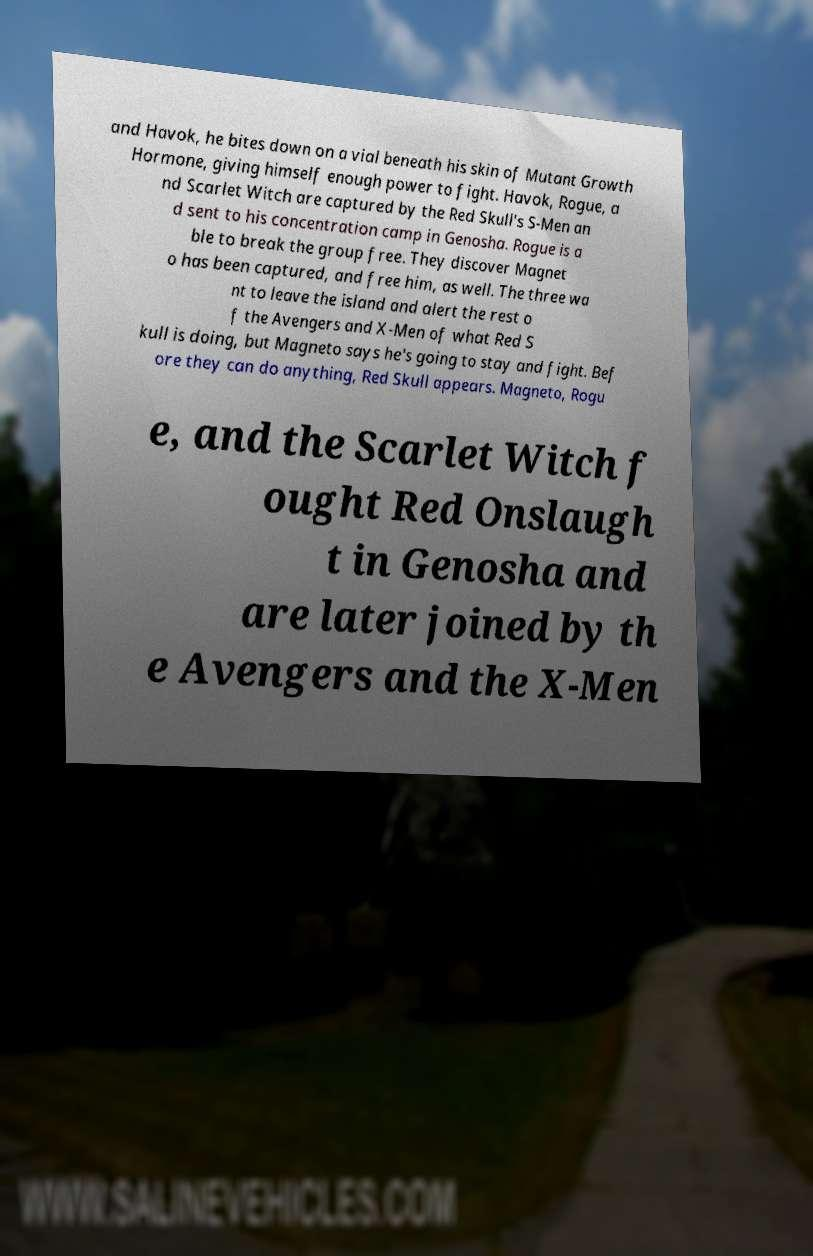For documentation purposes, I need the text within this image transcribed. Could you provide that? and Havok, he bites down on a vial beneath his skin of Mutant Growth Hormone, giving himself enough power to fight. Havok, Rogue, a nd Scarlet Witch are captured by the Red Skull's S-Men an d sent to his concentration camp in Genosha. Rogue is a ble to break the group free. They discover Magnet o has been captured, and free him, as well. The three wa nt to leave the island and alert the rest o f the Avengers and X-Men of what Red S kull is doing, but Magneto says he's going to stay and fight. Bef ore they can do anything, Red Skull appears. Magneto, Rogu e, and the Scarlet Witch f ought Red Onslaugh t in Genosha and are later joined by th e Avengers and the X-Men 